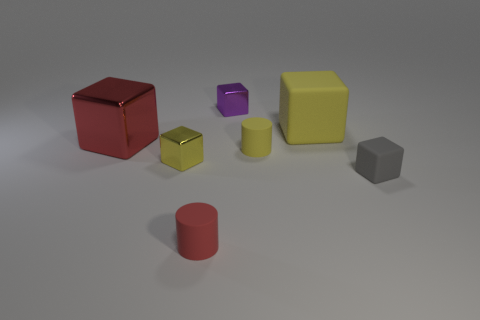The red cube seems prominent; what could be its significance or function in this arrangement? In this context, the red cube stands out due to its vibrant color and substantial size relative to the other objects. While its exact function is unclear without additional information, it could represent an important element in a compositional study or possibly be used as a point of visual interest or comparison. Could the cube serve a practical purpose, or is it purely aesthetic? Without more context, it's difficult to ascribe a practical purpose to the cube, so it may be purely aesthetic. Its presence could be intended to draw the viewer's eye or to serve as a reference for size, color, or geometry in a visual composition. 